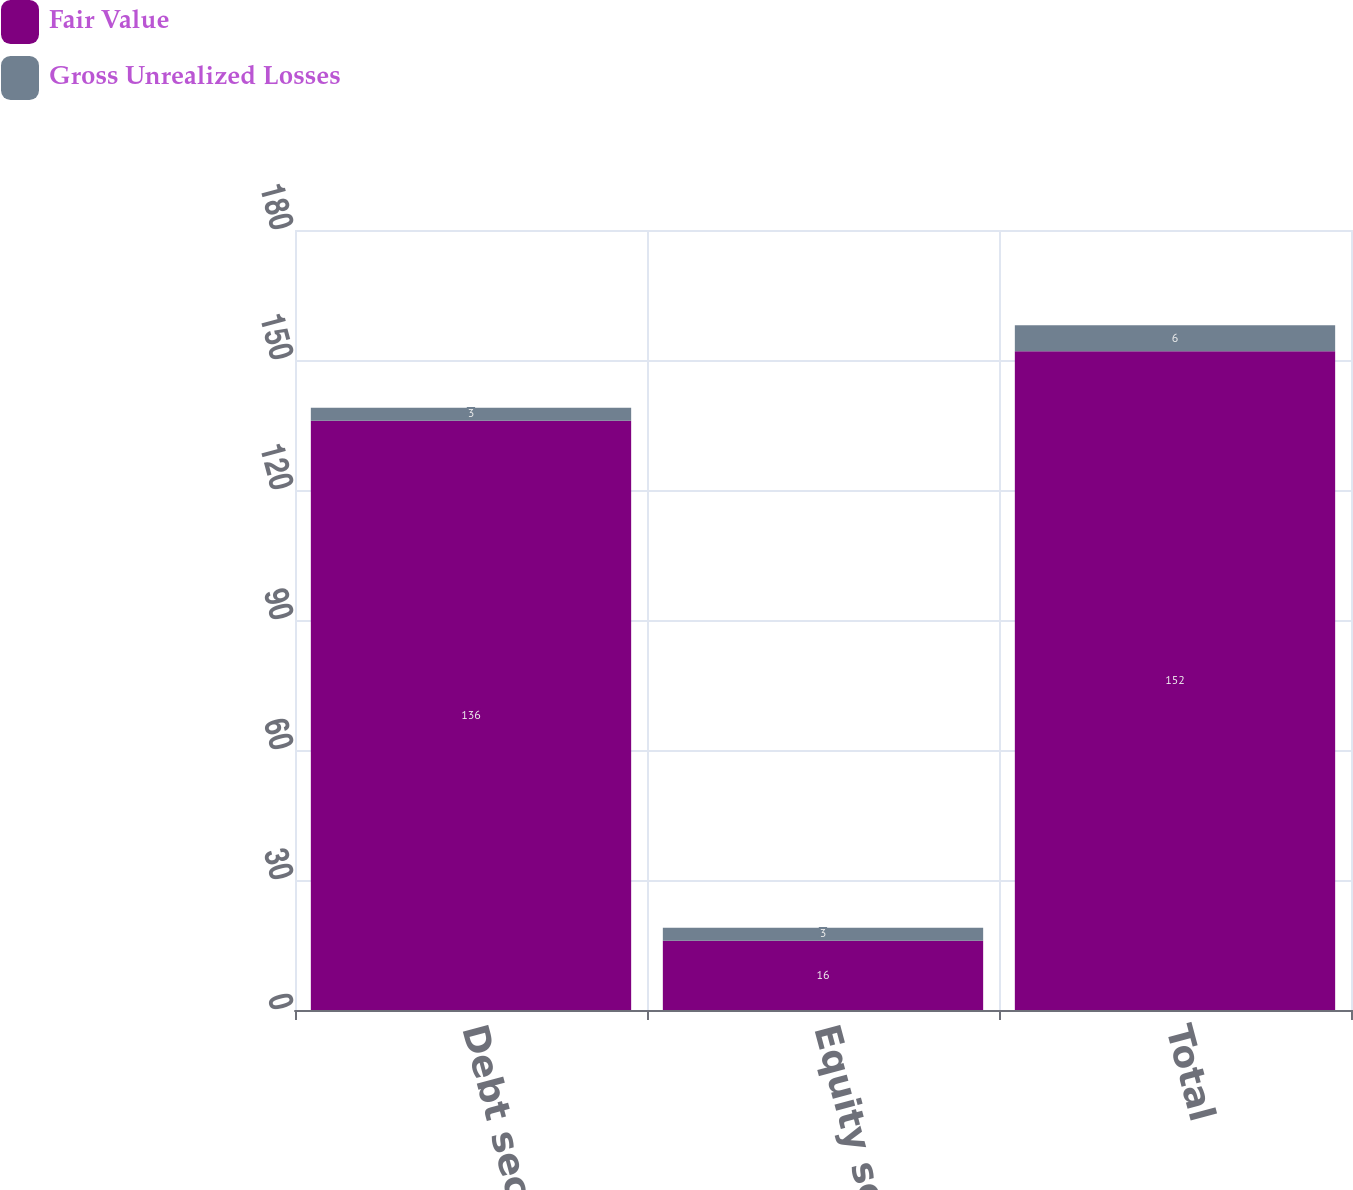Convert chart. <chart><loc_0><loc_0><loc_500><loc_500><stacked_bar_chart><ecel><fcel>Debt securities<fcel>Equity securities<fcel>Total<nl><fcel>Fair Value<fcel>136<fcel>16<fcel>152<nl><fcel>Gross Unrealized Losses<fcel>3<fcel>3<fcel>6<nl></chart> 